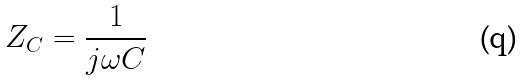<formula> <loc_0><loc_0><loc_500><loc_500>Z _ { C } = \frac { 1 } { j \omega C }</formula> 